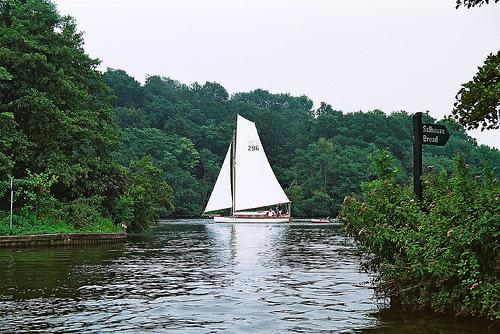Question: where is this scene?
Choices:
A. Ocean.
B. Jungle.
C. City.
D. Waterbody.
Answer with the letter. Answer: D Question: what is reflecting?
Choices:
A. Water.
B. Heat.
C. Light.
D. Sound.
Answer with the letter. Answer: A Question: what color is the boat?
Choices:
A. White.
B. Red.
C. Green.
D. Blue.
Answer with the letter. Answer: A Question: what type of scene is this?
Choices:
A. Indoor.
B. Nature.
C. Outdoor.
D. Dramatic.
Answer with the letter. Answer: C 